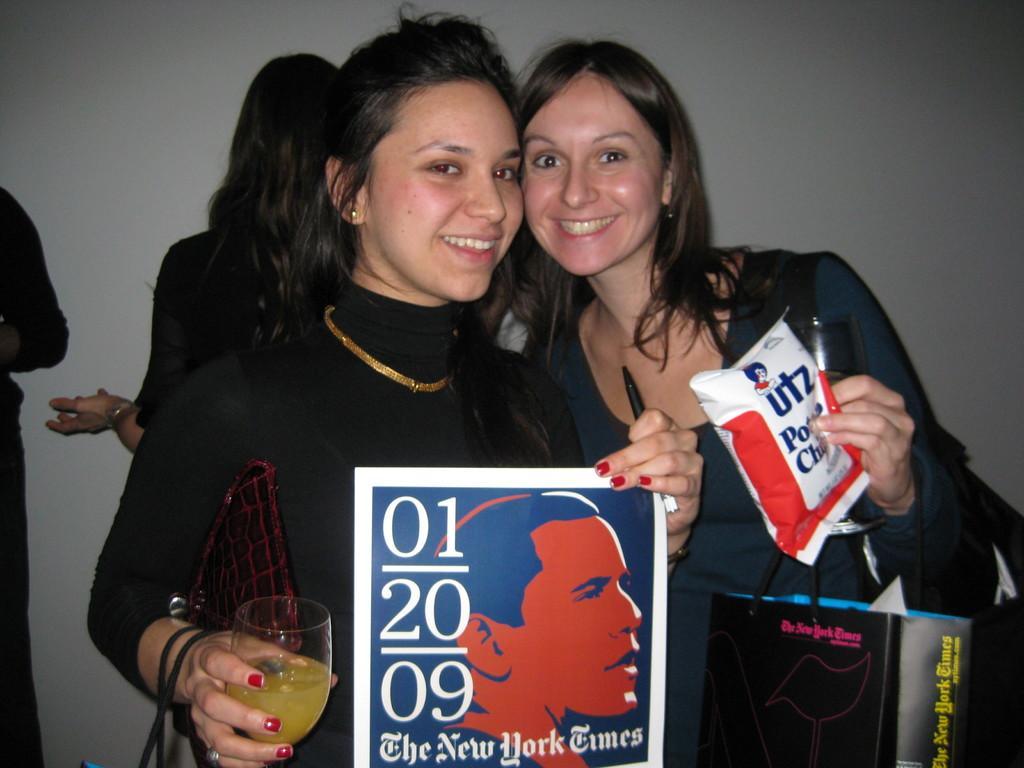How would you summarize this image in a sentence or two? This picture is mainly highlighted with a two beautiful women and they are holding a beautiful smile on their faces. They are in black attire and they both are holding some posters in their hands. On the right side we can see a women holding a carry bag in her hand and also a packet. On the left side we can see another women holding a sketch in her hand and also glass of juice in the other hand. Behind to them there are two persons standing. On the background we can see a wall. 